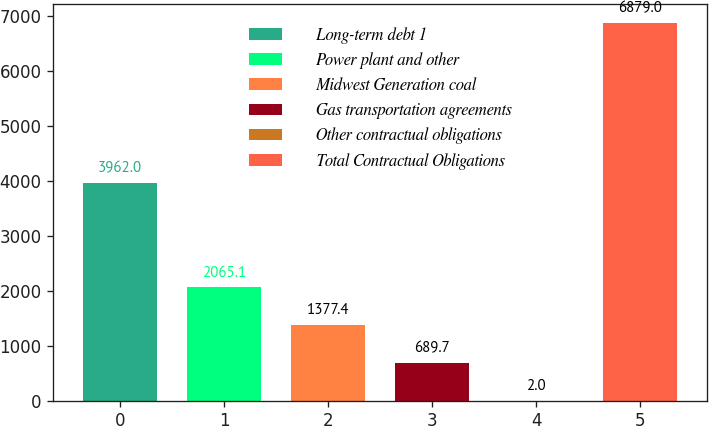Convert chart. <chart><loc_0><loc_0><loc_500><loc_500><bar_chart><fcel>Long-term debt 1<fcel>Power plant and other<fcel>Midwest Generation coal<fcel>Gas transportation agreements<fcel>Other contractual obligations<fcel>Total Contractual Obligations<nl><fcel>3962<fcel>2065.1<fcel>1377.4<fcel>689.7<fcel>2<fcel>6879<nl></chart> 